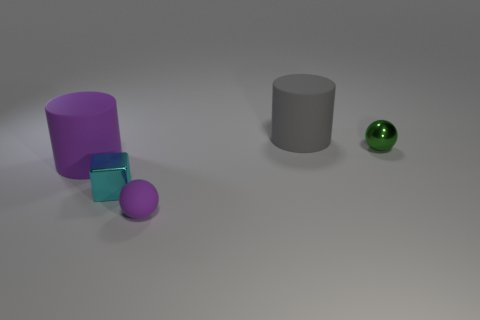Subtract all purple spheres. How many spheres are left? 1 Subtract all balls. How many objects are left? 3 Add 4 big gray matte things. How many objects exist? 9 Subtract 1 blocks. How many blocks are left? 0 Subtract all green cylinders. Subtract all purple spheres. How many cylinders are left? 2 Subtract all green blocks. How many green balls are left? 1 Subtract all gray shiny cylinders. Subtract all blocks. How many objects are left? 4 Add 3 metallic balls. How many metallic balls are left? 4 Add 5 brown objects. How many brown objects exist? 5 Subtract 0 blue cylinders. How many objects are left? 5 